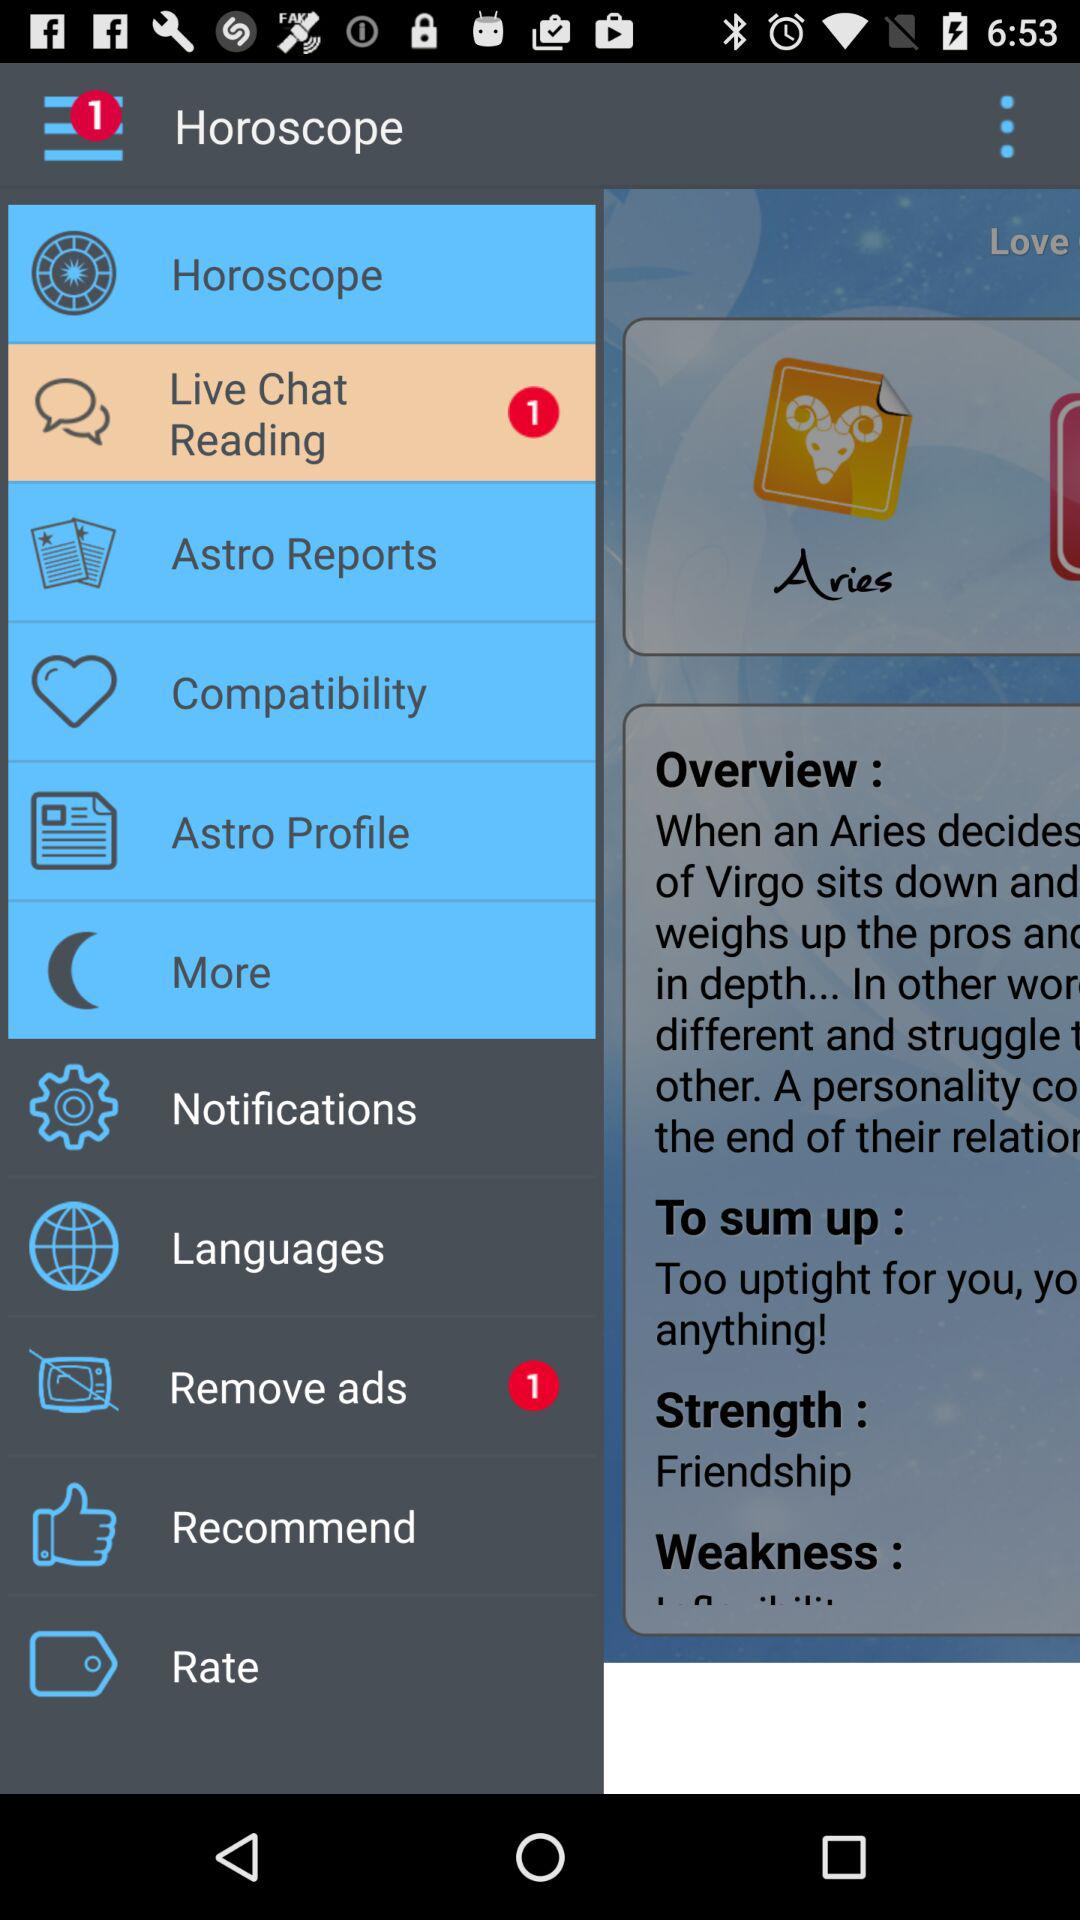Is there any unread live chat? There is 1 unread live chat. 